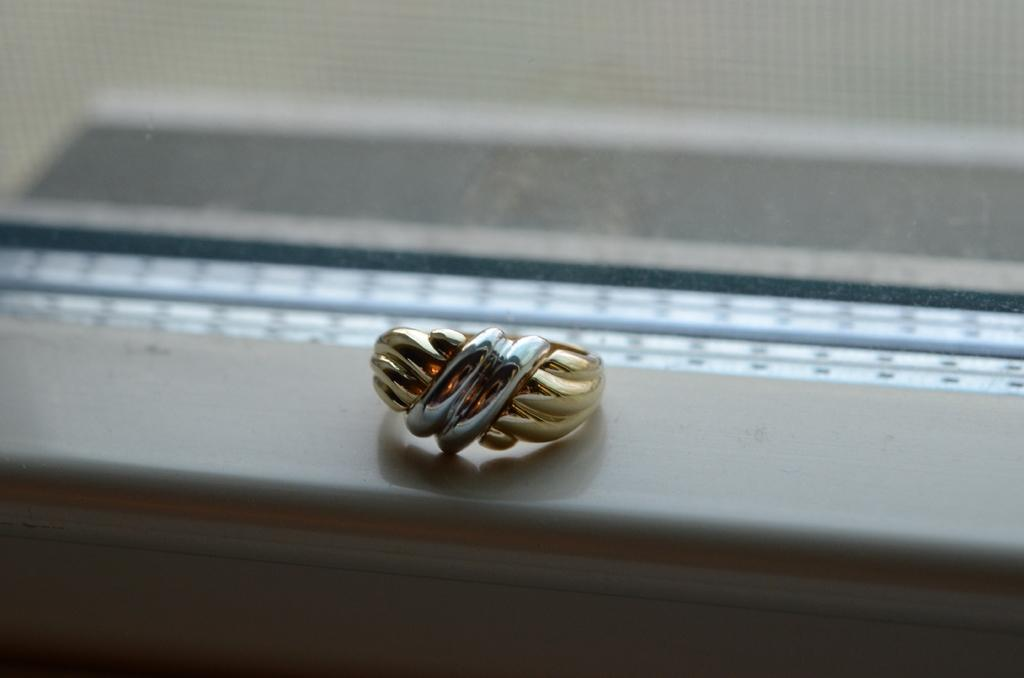What is the main object in the image? There is an object that looks like a ring in the image. Where is the ring placed? The ring is placed on a white surface. What does the white surface resemble? The white surface resembles a wall. How would you describe the background of the image? The background of the image is blurred. How does the ring compare to the muscle in the image? There is no muscle present in the image; it only features a ring placed on a white surface with a blurred background. 